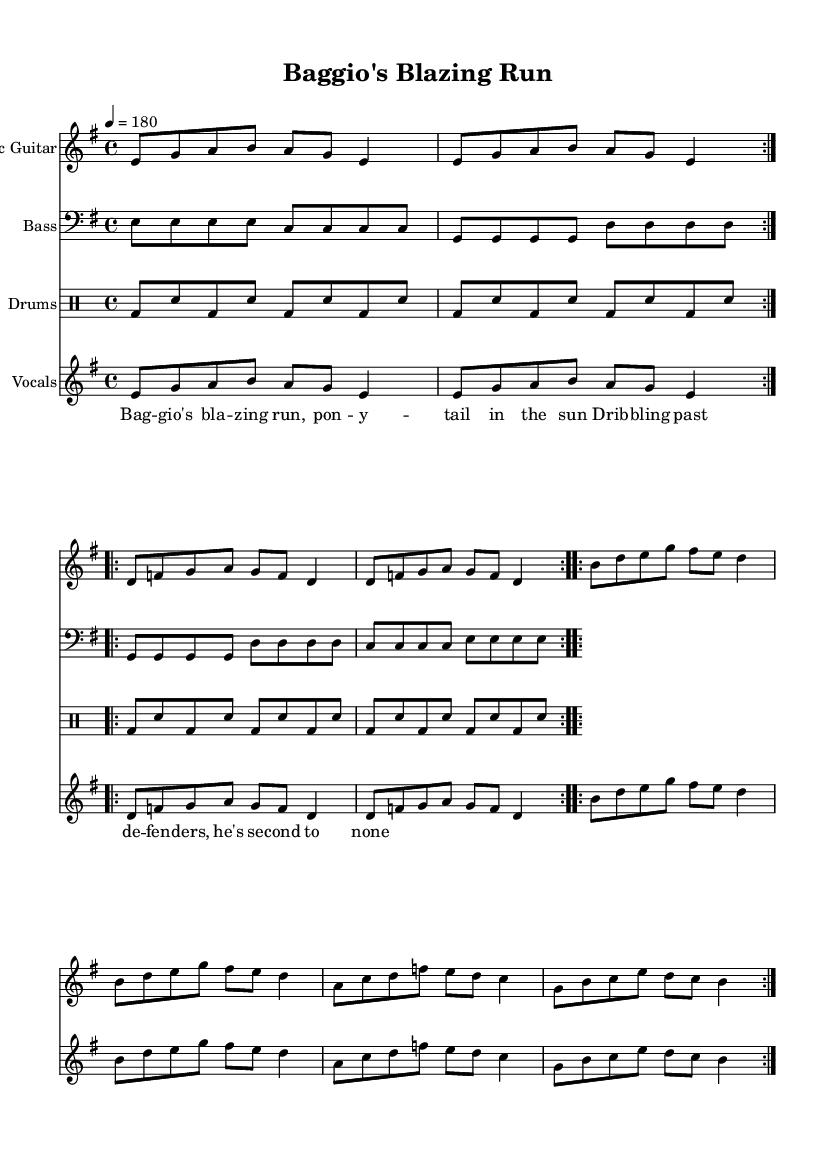What is the time signature of this music? The time signature is indicated at the beginning of the score, showing a '4/4' time signature, which means there are four beats per measure.
Answer: 4/4 What is the key signature of this music? The key signature is found at the start of the piece, showing two sharps, indicating that it is in E minor.
Answer: E minor What is the tempo marking of this piece? The tempo marking appears directly above the staff, indicating that the piece should be played at a 'quarter note equals 180 beats per minute.'
Answer: 180 How many times does the electric guitar part repeat in the first section? The electric guitar part is marked with 'volta 2,' which means that the section is to be played two times in total.
Answer: 2 What main theme does the vocal line reference in this piece? The lyrics reference a famous soccer player, Roberto Baggio, indicating that the song's main theme is inspired by his football skills.
Answer: Roberto Baggio What is the overall structure of the bass guitar part? The bass guitar part consists of alternating notes in a repetitive pattern that complements the rhythmic drive typical in punk rock.
Answer: Repetitive pattern How does the drum part contribute to the punk rock feel? The drum part consists of a consistent bass-snare pattern, which provides a strong and driving rhythm essential for punk rock's fast-paced sound.
Answer: Strong rhythm 